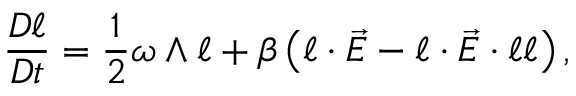<formula> <loc_0><loc_0><loc_500><loc_500>\frac { D \ell } { D t } = \frac { 1 } { 2 } \omega \wedge \ell + \beta \left ( \ell \cdot \vec { E } - \ell \cdot \vec { E } \cdot \ell \ell \right ) ,</formula> 